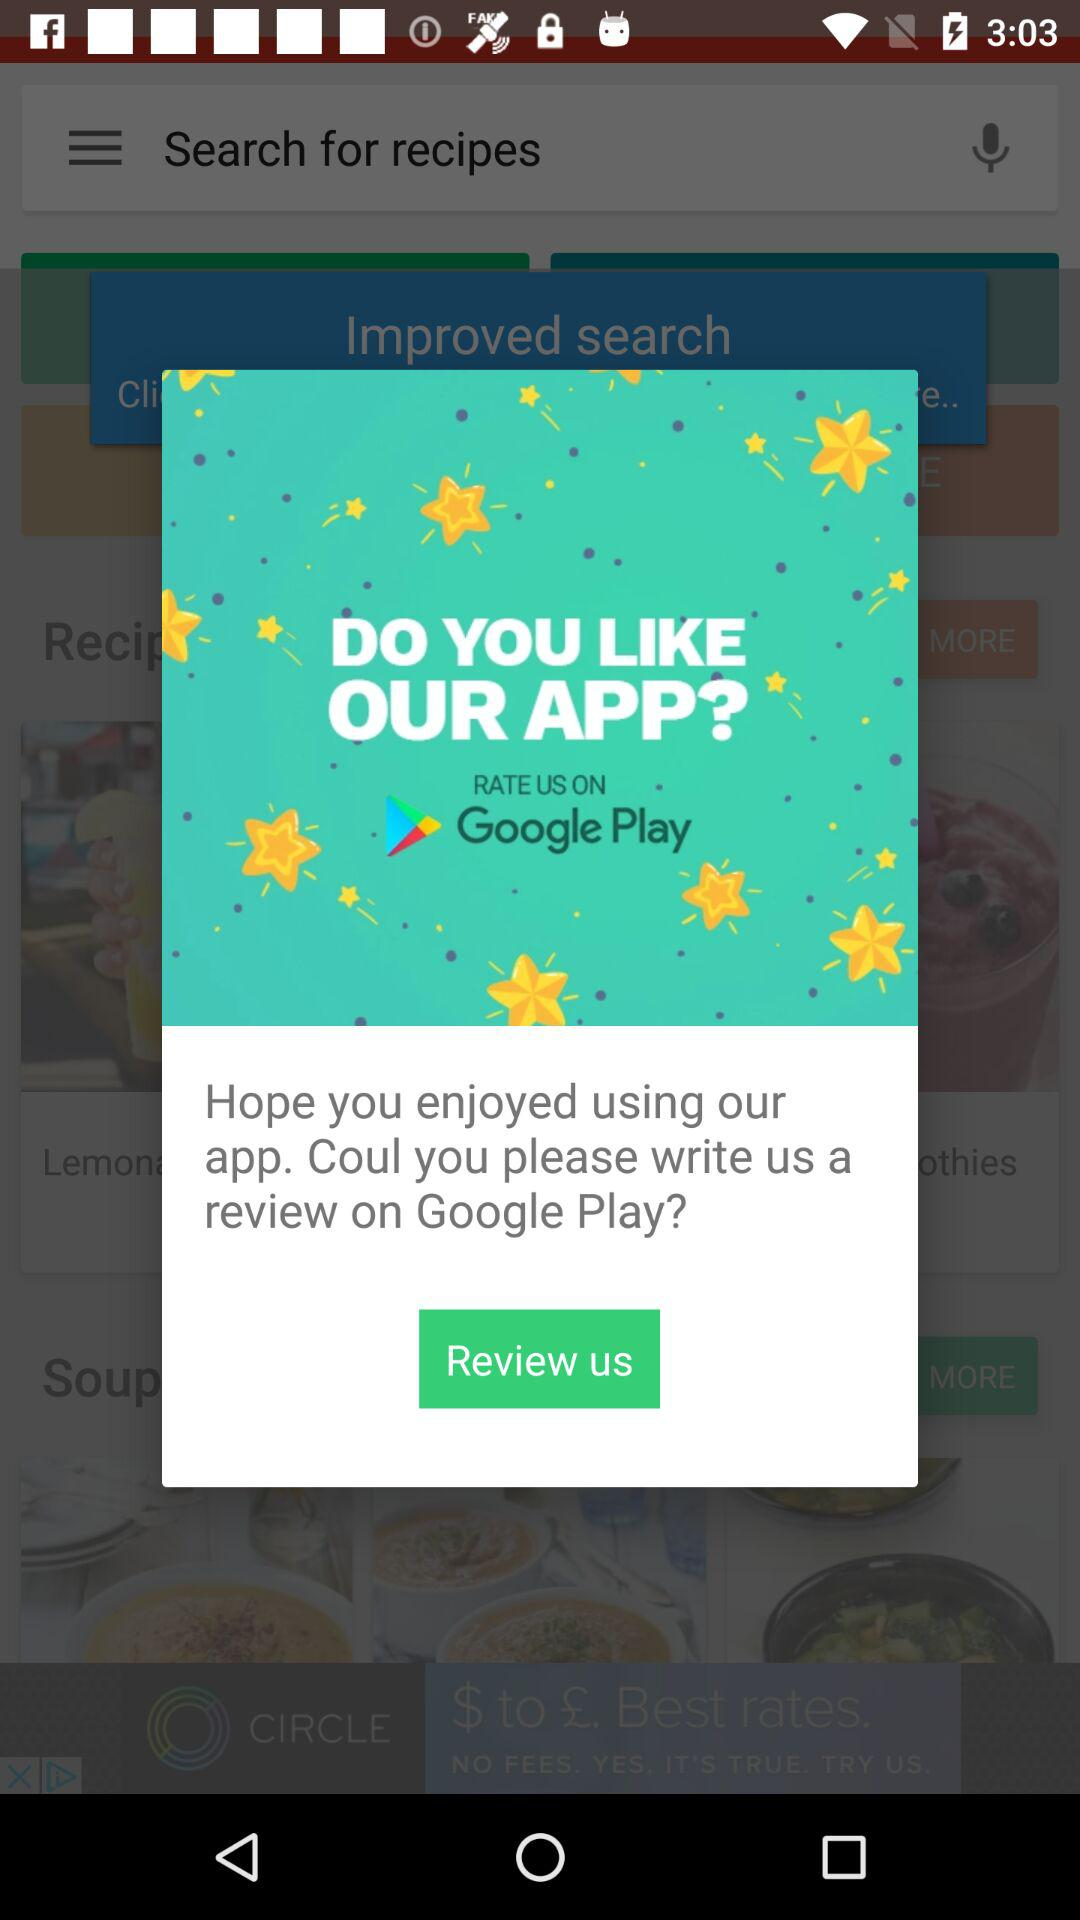What's the application name on which the user can write the review? The application name on which the user can write the review is "Google Play". 